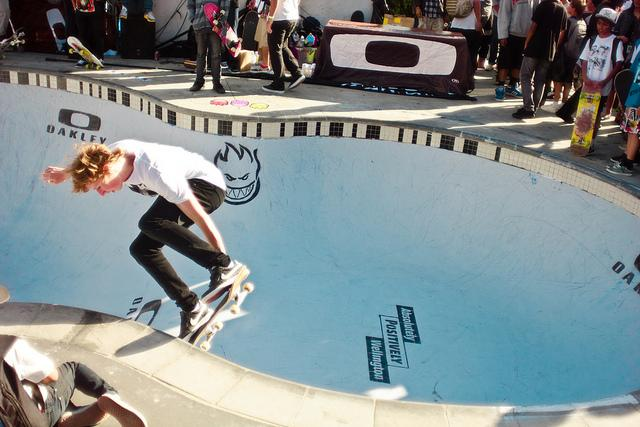What's happening to this guy? Please explain your reasoning. doing tricks. The man is using a skateboard to perform. 